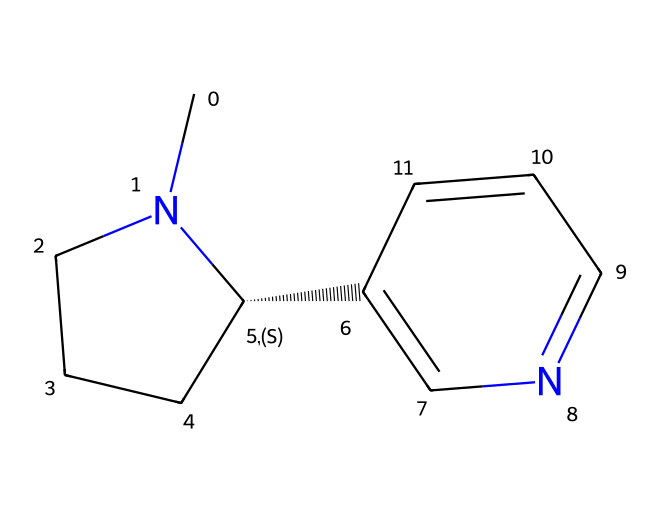What is the molecular formula of nicotine? To determine the molecular formula from the SMILES representation, I count the number of each type of atom. There are 10 carbon atoms (C), 14 hydrogen atoms (H), and 2 nitrogen atoms (N). Therefore, combining these gives the formula C10H14N2.
Answer: C10H14N2 How many rings are present in the nicotine structure? By analyzing the structure, there is one six-membered ring and one five-membered ring, totaling two rings.
Answer: 2 What functional groups can be identified in nicotine? In this structure, the presence of nitrogen contributes to the basicity, hinting at its classification as a base. The presence of carbon and nitrogen alone suggests it may contain amine groups, as well as the alkaloid structure commonly found in such compounds.
Answer: amine Is nicotine a strong or weak base? The presence of nitrogen atoms in its structure typically allows nicotine to accept protons, categorizing it as a weak base since it does not dissociate completely in solution.
Answer: weak How does the nitrogen in nicotine affect its solubility? The nitrogen atom increases the polarity of the nicotine molecule, which consequently enhances its solubility in water compared to non-polar hydrocarbons. This is due to the ability of nitrogen to form hydrogen bonds with water molecules.
Answer: increases What is the significance of the double bond in the nicotine structure? The double bond influences the molecular rigidity and affects the reactivity of the molecule, potentially impacting how nicotine interacts with receptors in biological systems, particularly in achieving its pharmacological effects.
Answer: affects reactivity 